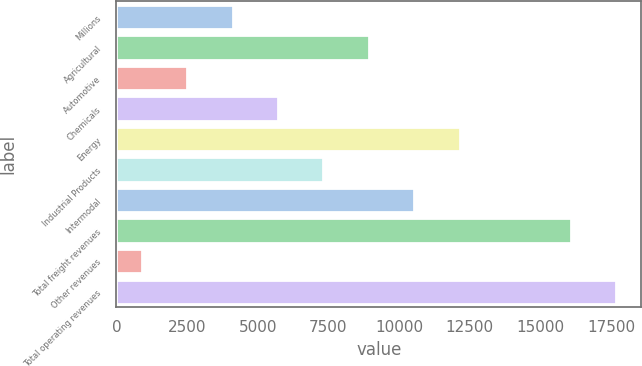Convert chart. <chart><loc_0><loc_0><loc_500><loc_500><bar_chart><fcel>Millions<fcel>Agricultural<fcel>Automotive<fcel>Chemicals<fcel>Energy<fcel>Industrial Products<fcel>Intermodal<fcel>Total freight revenues<fcel>Other revenues<fcel>Total operating revenues<nl><fcel>4109.8<fcel>8930.5<fcel>2502.9<fcel>5716.7<fcel>12144.3<fcel>7323.6<fcel>10537.4<fcel>16069<fcel>896<fcel>17675.9<nl></chart> 